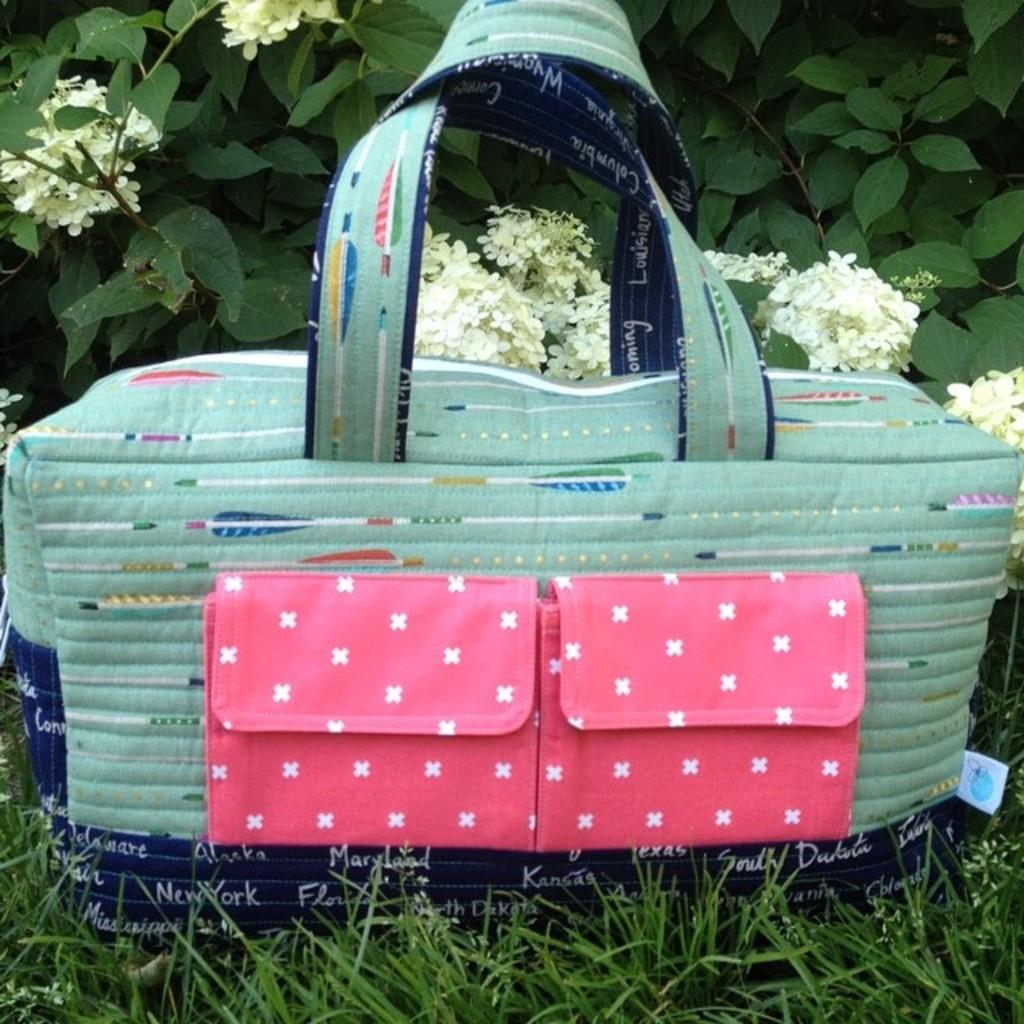What object can be seen in the image? There is a handbag in the image. Where is the handbag located? The handbag is on the grass. What type of vegetation is present in the image? There are plants with flowers in the image. What game is being played on the sidewalk in the image? There is no game or sidewalk present in the image; it features a handbag on the grass and plants with flowers. 